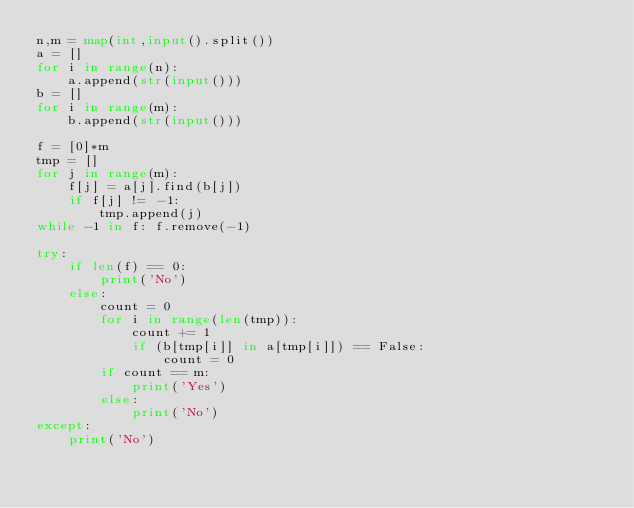Convert code to text. <code><loc_0><loc_0><loc_500><loc_500><_Python_>n,m = map(int,input().split())
a = []
for i in range(n):
    a.append(str(input()))
b = []
for i in range(m):
    b.append(str(input()))

f = [0]*m
tmp = []
for j in range(m):
    f[j] = a[j].find(b[j])
    if f[j] != -1:
        tmp.append(j)
while -1 in f: f.remove(-1)

try:
    if len(f) == 0:
        print('No')
    else:
        count = 0
        for i in range(len(tmp)):
            count += 1
            if (b[tmp[i]] in a[tmp[i]]) == False:
                count = 0
        if count == m:
            print('Yes')
        else:
            print('No')
except:
    print('No')</code> 